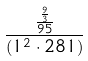<formula> <loc_0><loc_0><loc_500><loc_500>\frac { \frac { \frac { 9 } { 3 } } { 9 5 } } { ( 1 ^ { 2 } \cdot 2 8 1 ) }</formula> 